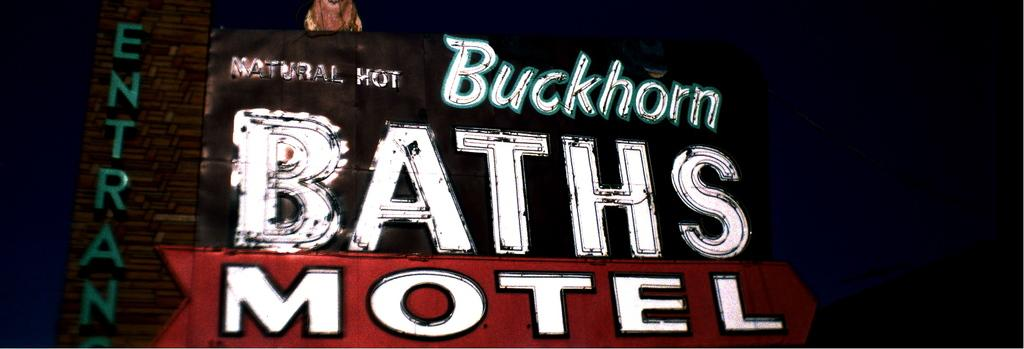<image>
Offer a succinct explanation of the picture presented. A neon sign for Buckhorn Baths and Motel. 